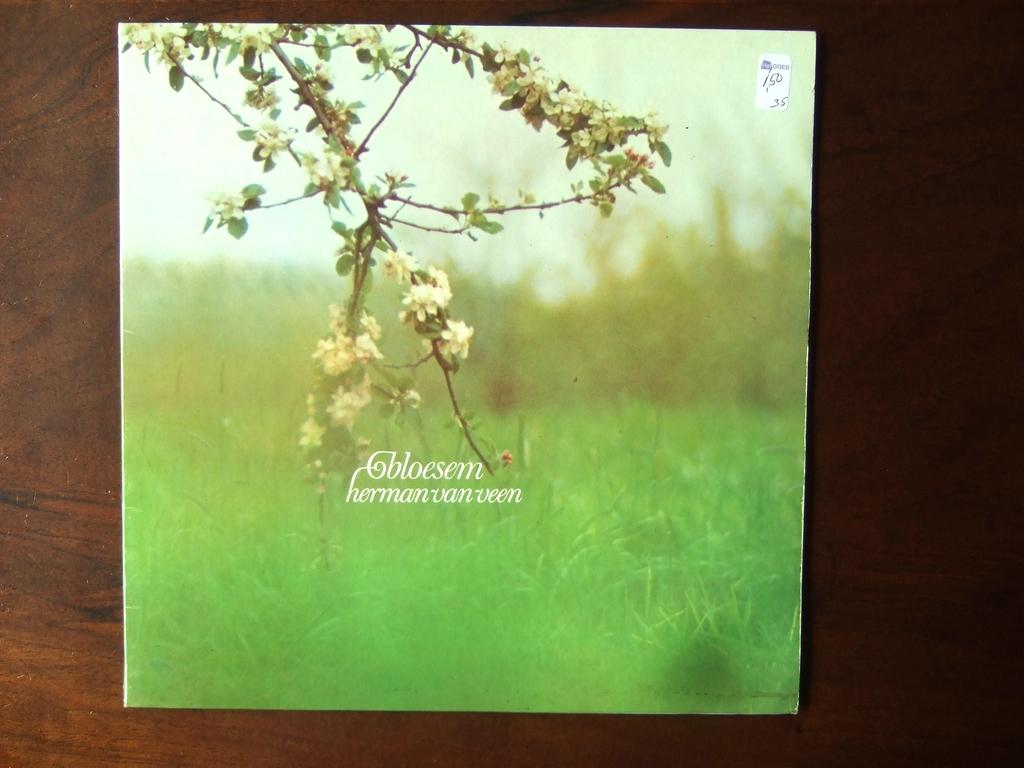What is placed on the platform in the image? There is a card on a platform. What is depicted at the bottom of the card? The card has grass at the bottom. What type of plant can be seen on the card? There is a plant with flowers on the card. What can be seen in the background of the image? The background of the image is blurred, but the sky is visible. How does the plant on the card use its leg to reach the sky? The plant on the card does not have a leg, as it is a stationary image and not a living organism. 